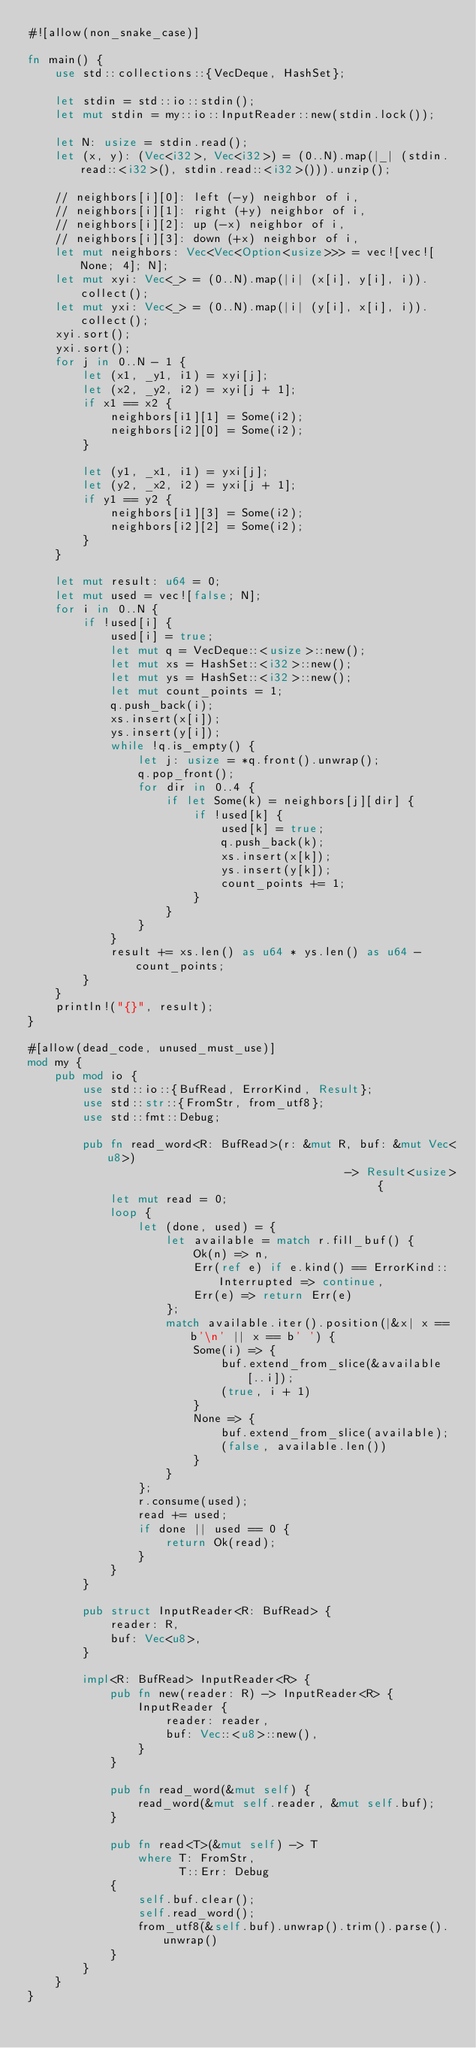<code> <loc_0><loc_0><loc_500><loc_500><_Rust_>#![allow(non_snake_case)]

fn main() {
    use std::collections::{VecDeque, HashSet};

    let stdin = std::io::stdin();
    let mut stdin = my::io::InputReader::new(stdin.lock());
    
    let N: usize = stdin.read();
    let (x, y): (Vec<i32>, Vec<i32>) = (0..N).map(|_| (stdin.read::<i32>(), stdin.read::<i32>())).unzip();

    // neighbors[i][0]: left (-y) neighbor of i,
    // neighbors[i][1]: right (+y) neighbor of i,
    // neighbors[i][2]: up (-x) neighbor of i,
    // neighbors[i][3]: down (+x) neighbor of i,
    let mut neighbors: Vec<Vec<Option<usize>>> = vec![vec![None; 4]; N];
    let mut xyi: Vec<_> = (0..N).map(|i| (x[i], y[i], i)).collect();
    let mut yxi: Vec<_> = (0..N).map(|i| (y[i], x[i], i)).collect();
    xyi.sort();
    yxi.sort();
    for j in 0..N - 1 {
        let (x1, _y1, i1) = xyi[j];
        let (x2, _y2, i2) = xyi[j + 1];
        if x1 == x2 {
            neighbors[i1][1] = Some(i2);
            neighbors[i2][0] = Some(i2);
        }

        let (y1, _x1, i1) = yxi[j];
        let (y2, _x2, i2) = yxi[j + 1];
        if y1 == y2 {
            neighbors[i1][3] = Some(i2);
            neighbors[i2][2] = Some(i2);
        }
    }

    let mut result: u64 = 0;
    let mut used = vec![false; N];
    for i in 0..N {
        if !used[i] {
            used[i] = true;
            let mut q = VecDeque::<usize>::new();
            let mut xs = HashSet::<i32>::new();
            let mut ys = HashSet::<i32>::new();
            let mut count_points = 1;
            q.push_back(i);
            xs.insert(x[i]);
            ys.insert(y[i]);
            while !q.is_empty() {
                let j: usize = *q.front().unwrap();
                q.pop_front();
                for dir in 0..4 {
                    if let Some(k) = neighbors[j][dir] {
                        if !used[k] {
                            used[k] = true;
                            q.push_back(k);
                            xs.insert(x[k]);
                            ys.insert(y[k]);
                            count_points += 1;
                        }
                    }
                }
            }
            result += xs.len() as u64 * ys.len() as u64 - count_points;
        }
    }
    println!("{}", result);
}

#[allow(dead_code, unused_must_use)]
mod my {
    pub mod io {
        use std::io::{BufRead, ErrorKind, Result};
        use std::str::{FromStr, from_utf8};
        use std::fmt::Debug;

        pub fn read_word<R: BufRead>(r: &mut R, buf: &mut Vec<u8>)
                                              -> Result<usize> {
            let mut read = 0;
            loop {
                let (done, used) = {
                    let available = match r.fill_buf() {
                        Ok(n) => n,
                        Err(ref e) if e.kind() == ErrorKind::Interrupted => continue,
                        Err(e) => return Err(e)
                    };
                    match available.iter().position(|&x| x == b'\n' || x == b' ') {
                        Some(i) => {
                            buf.extend_from_slice(&available[..i]);
                            (true, i + 1)
                        }
                        None => {
                            buf.extend_from_slice(available);
                            (false, available.len())
                        }
                    }
                };
                r.consume(used);
                read += used;
                if done || used == 0 {
                    return Ok(read);
                }
            }
        }

        pub struct InputReader<R: BufRead> {
            reader: R,
            buf: Vec<u8>,
        }

        impl<R: BufRead> InputReader<R> {
            pub fn new(reader: R) -> InputReader<R> {
                InputReader {
                    reader: reader,
                    buf: Vec::<u8>::new(),
                }
            }

            pub fn read_word(&mut self) {
                read_word(&mut self.reader, &mut self.buf);
            }
            
            pub fn read<T>(&mut self) -> T
                where T: FromStr,
                      T::Err: Debug
            {
                self.buf.clear();
                self.read_word();
                from_utf8(&self.buf).unwrap().trim().parse().unwrap()
            }
        }
    }
}</code> 